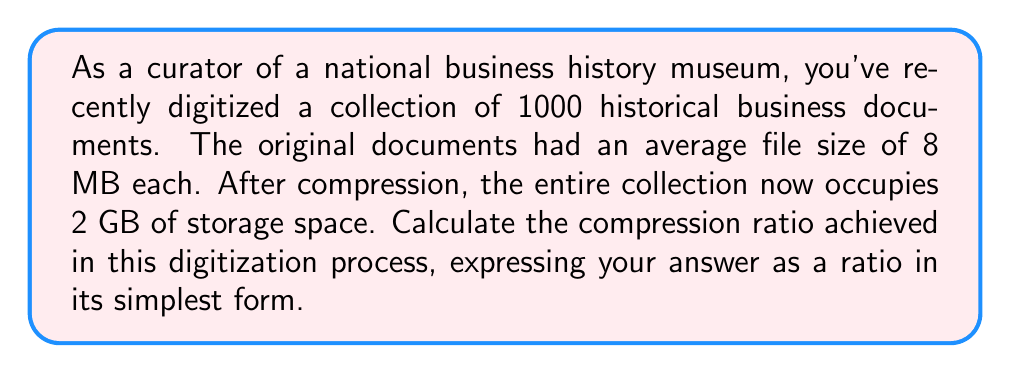Solve this math problem. To solve this problem, we need to follow these steps:

1. Calculate the total size of the original documents:
   $$1000 \text{ documents} \times 8 \text{ MB} = 8000 \text{ MB}$$

2. Convert the compressed size from GB to MB:
   $$2 \text{ GB} = 2 \times 1024 \text{ MB} = 2048 \text{ MB}$$

3. Calculate the compression ratio using the formula:
   $$\text{Compression Ratio} = \frac{\text{Original Size}}{\text{Compressed Size}}$$

   $$\text{Compression Ratio} = \frac{8000 \text{ MB}}{2048 \text{ MB}}$$

4. Simplify the ratio:
   $$\frac{8000}{2048} = \frac{8000 \div 64}{2048 \div 64} = \frac{125}{32}$$

Therefore, the compression ratio is 125:32.
Answer: 125:32 